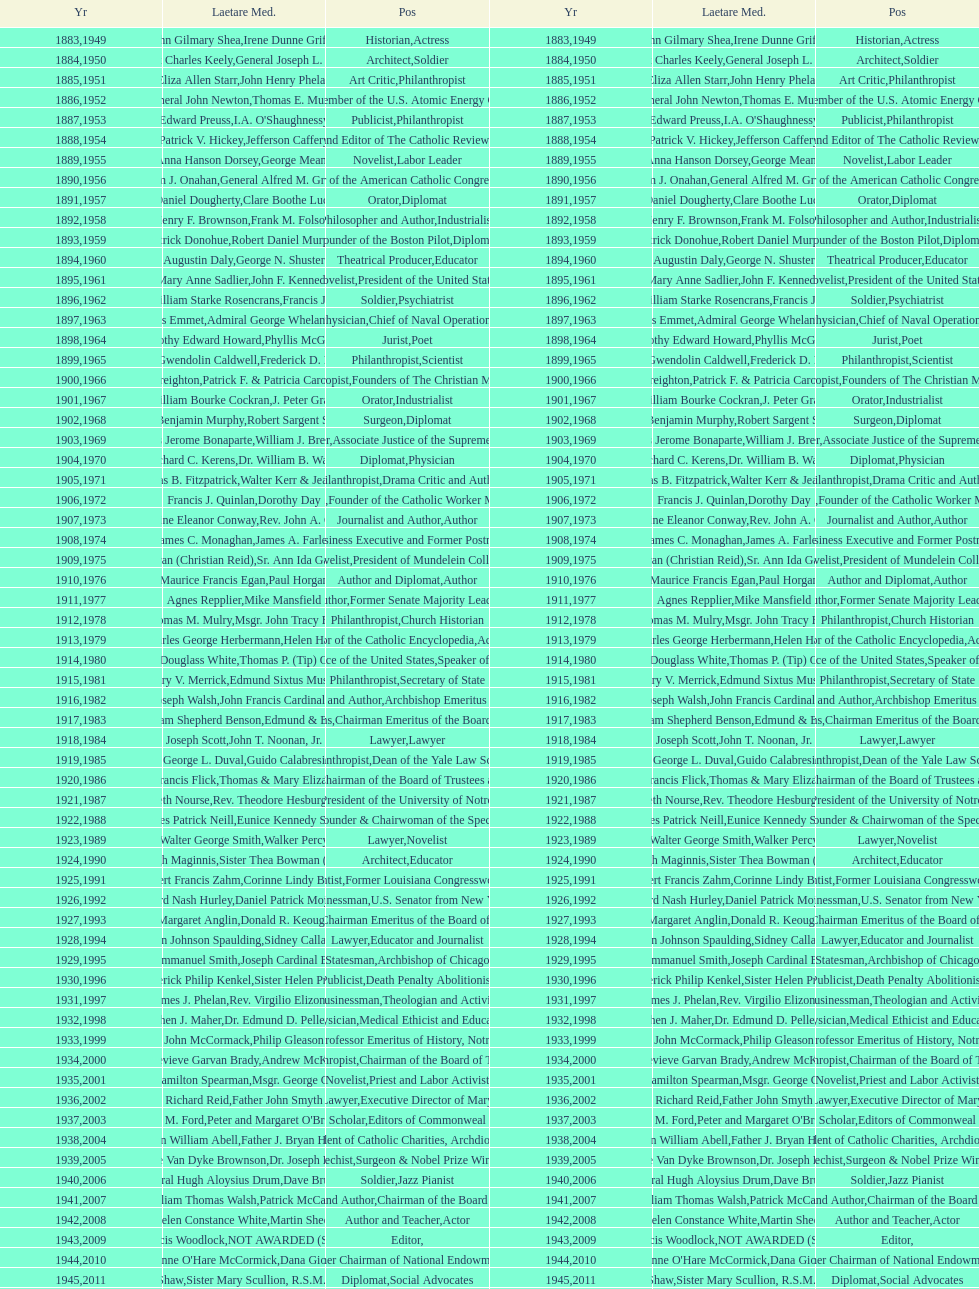Who was the previous winner before john henry phelan in 1951? General Joseph L. Collins. 